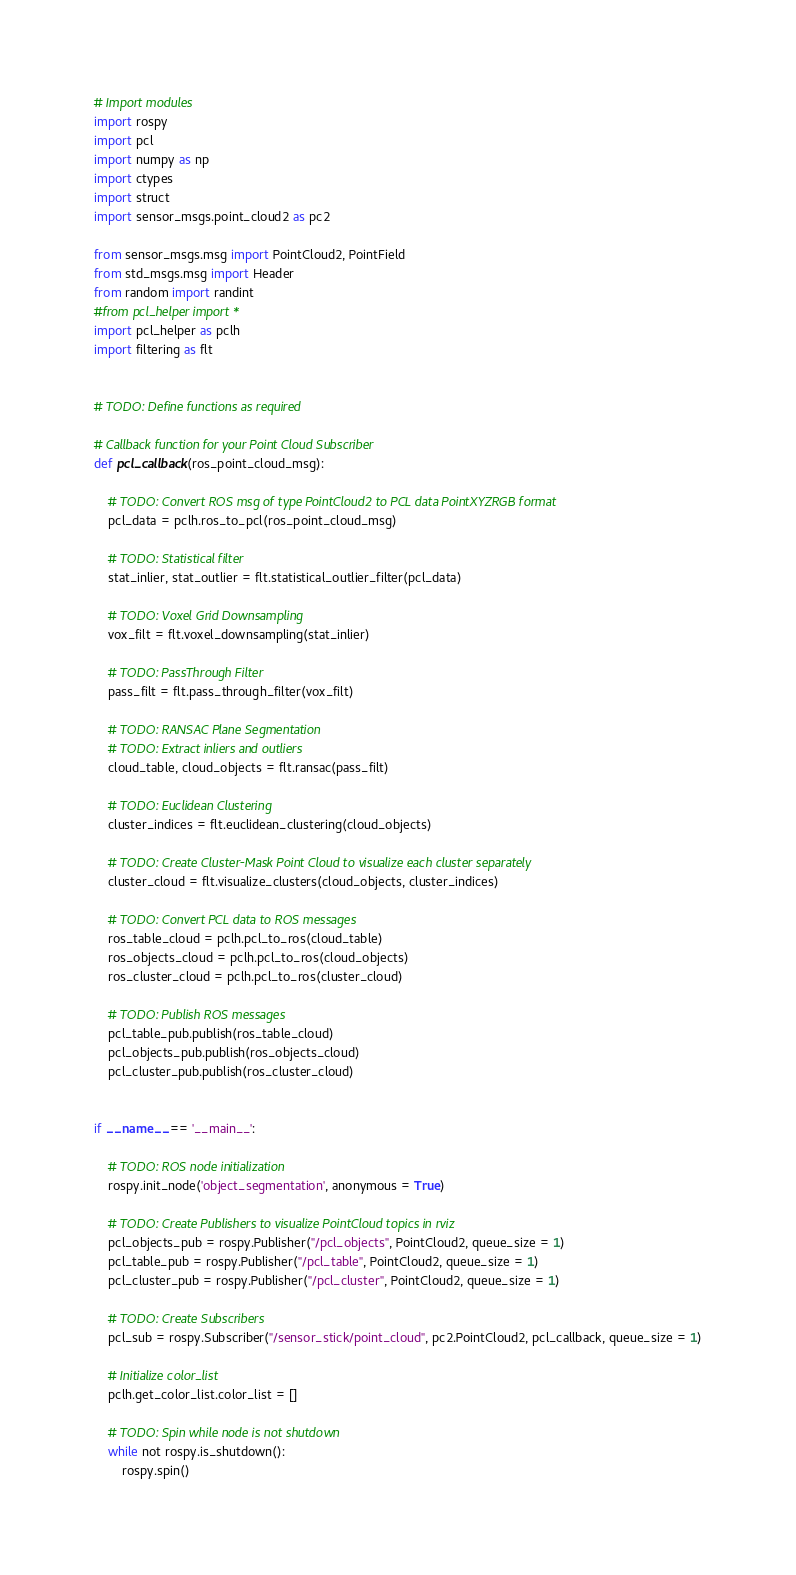Convert code to text. <code><loc_0><loc_0><loc_500><loc_500><_Python_># Import modules
import rospy
import pcl
import numpy as np
import ctypes
import struct
import sensor_msgs.point_cloud2 as pc2

from sensor_msgs.msg import PointCloud2, PointField
from std_msgs.msg import Header
from random import randint
#from pcl_helper import *
import pcl_helper as pclh
import filtering as flt


# TODO: Define functions as required

# Callback function for your Point Cloud Subscriber
def pcl_callback(ros_point_cloud_msg):

    # TODO: Convert ROS msg of type PointCloud2 to PCL data PointXYZRGB format
    pcl_data = pclh.ros_to_pcl(ros_point_cloud_msg)

    # TODO: Statistical filter
    stat_inlier, stat_outlier = flt.statistical_outlier_filter(pcl_data)
    
    # TODO: Voxel Grid Downsampling
    vox_filt = flt.voxel_downsampling(stat_inlier)

    # TODO: PassThrough Filter
    pass_filt = flt.pass_through_filter(vox_filt)
    
    # TODO: RANSAC Plane Segmentation
    # TODO: Extract inliers and outliers
    cloud_table, cloud_objects = flt.ransac(pass_filt)
    
    # TODO: Euclidean Clustering
    cluster_indices = flt.euclidean_clustering(cloud_objects)

    # TODO: Create Cluster-Mask Point Cloud to visualize each cluster separately
    cluster_cloud = flt.visualize_clusters(cloud_objects, cluster_indices)

    # TODO: Convert PCL data to ROS messages
    ros_table_cloud = pclh.pcl_to_ros(cloud_table)
    ros_objects_cloud = pclh.pcl_to_ros(cloud_objects)
    ros_cluster_cloud = pclh.pcl_to_ros(cluster_cloud)

    # TODO: Publish ROS messages
    pcl_table_pub.publish(ros_table_cloud)
    pcl_objects_pub.publish(ros_objects_cloud)
    pcl_cluster_pub.publish(ros_cluster_cloud)


if __name__ == '__main__':

    # TODO: ROS node initialization
    rospy.init_node('object_segmentation', anonymous = True)

    # TODO: Create Publishers to visualize PointCloud topics in rviz
    pcl_objects_pub = rospy.Publisher("/pcl_objects", PointCloud2, queue_size = 1)
    pcl_table_pub = rospy.Publisher("/pcl_table", PointCloud2, queue_size = 1)
    pcl_cluster_pub = rospy.Publisher("/pcl_cluster", PointCloud2, queue_size = 1)

    # TODO: Create Subscribers
    pcl_sub = rospy.Subscriber("/sensor_stick/point_cloud", pc2.PointCloud2, pcl_callback, queue_size = 1)
    
    # Initialize color_list
    pclh.get_color_list.color_list = []

    # TODO: Spin while node is not shutdown
    while not rospy.is_shutdown():
        rospy.spin()</code> 